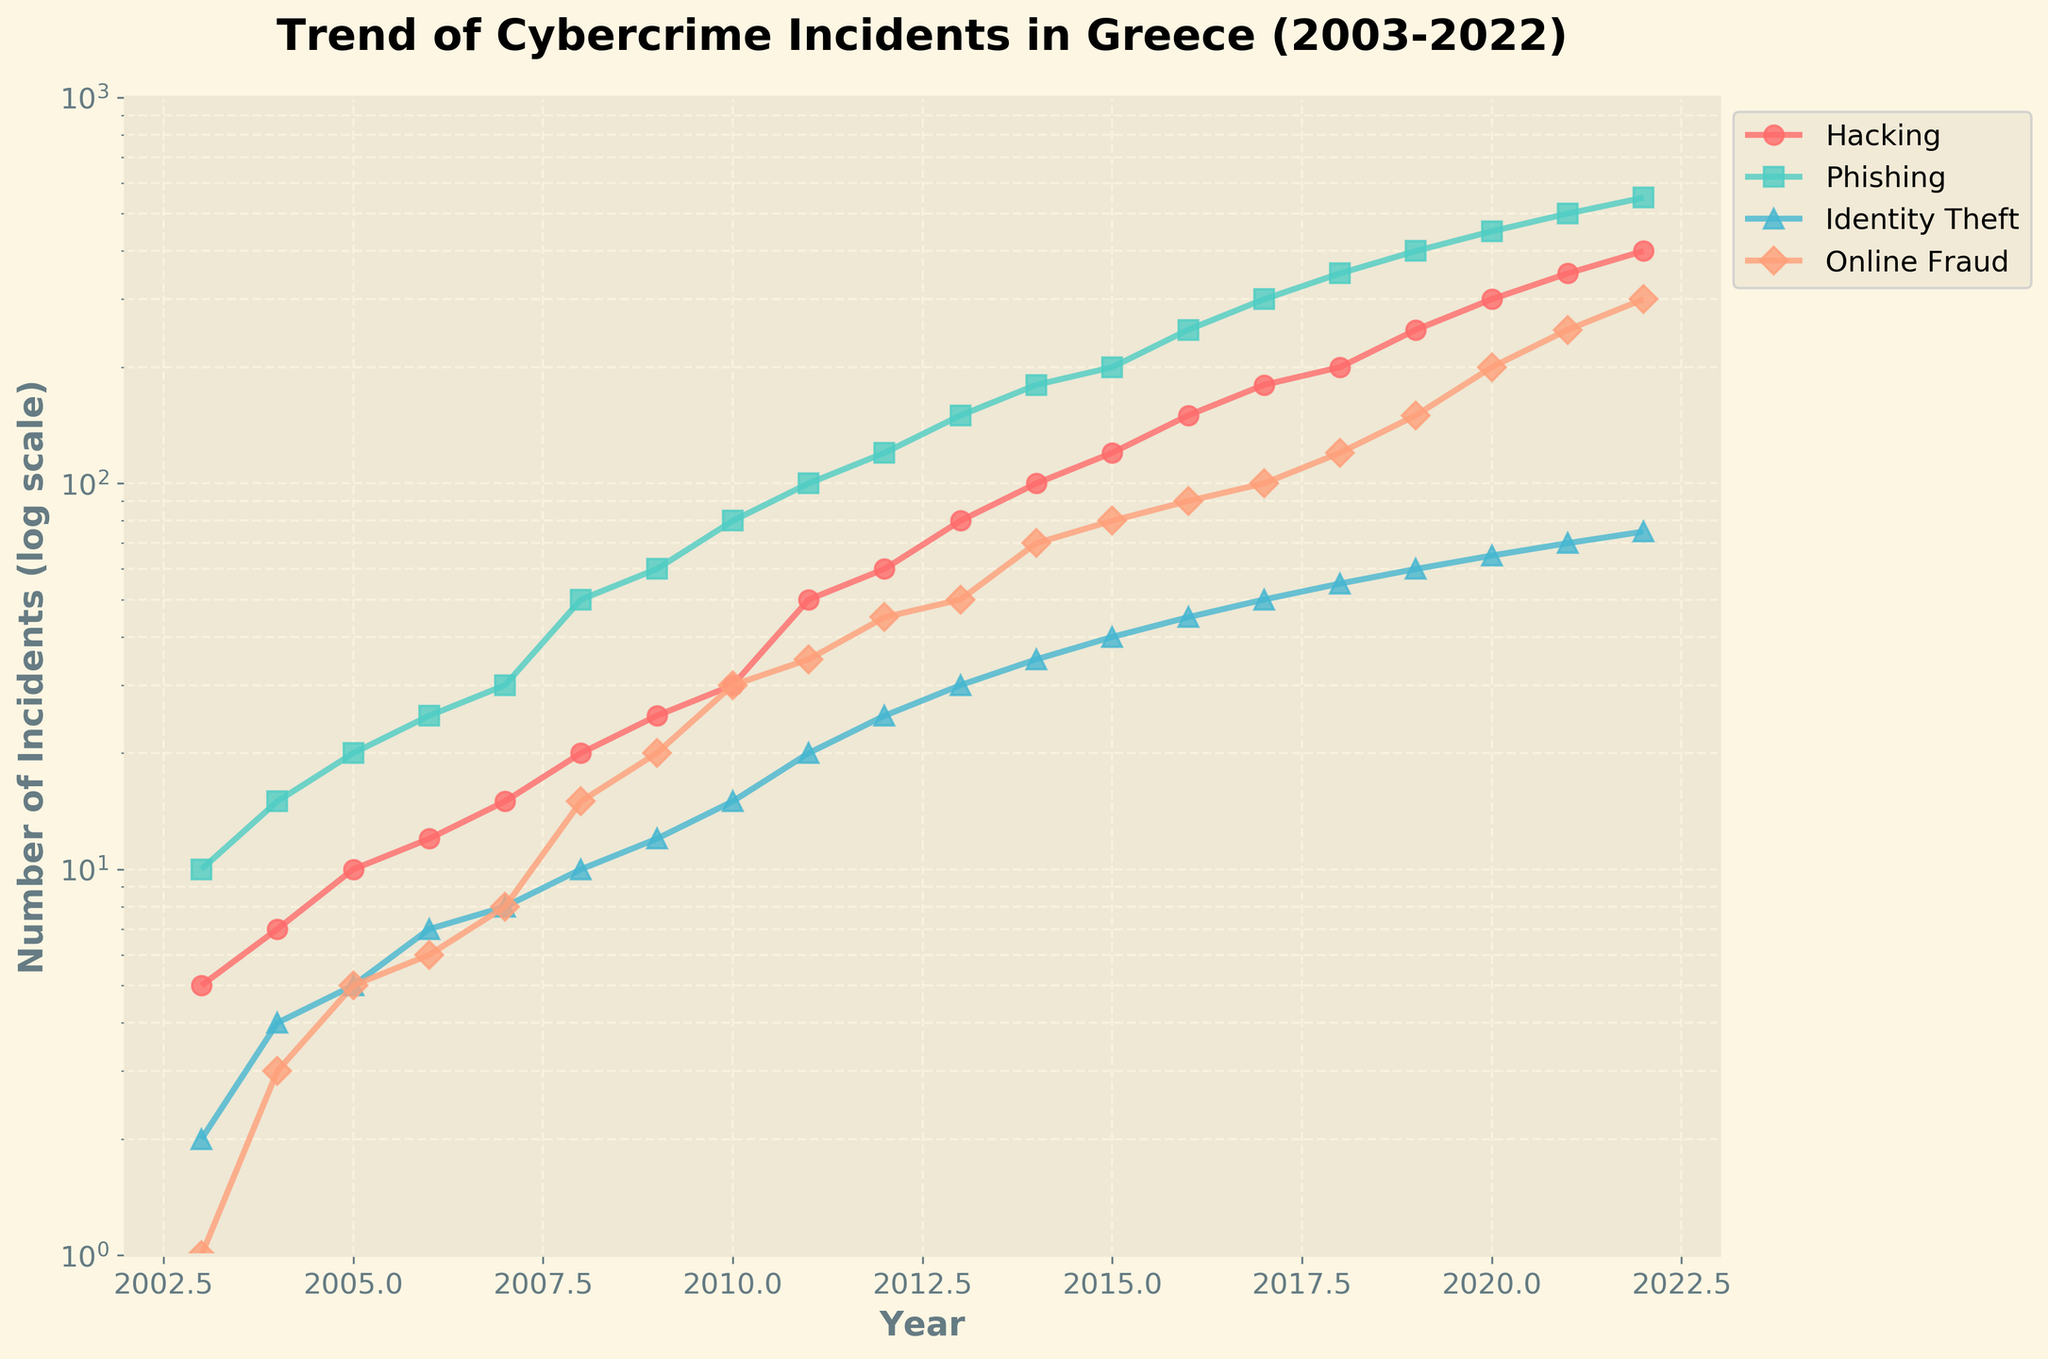What is the overall trend of cybercrime incidents reported in Greece from 2003 to 2022? The overall trend of cybercrime incidents reported in Greece shows a significant increase across all types of offenses over the last 20 years. This can be observed as all lines representing different types of cybercrimes are moving upward.
Answer: Increasing Which type of cybercrime had the highest number of reported incidents by 2022? By examining the end points of the lines for the year 2022, we see that 'Phishing' has the highest number of reported incidents. The line representing 'Phishing' is at the topmost position.
Answer: Phishing How does the increase in 'Identity Theft' incidents from 2003 to 2022 compare to the increase in 'Online Fraud' incidents? 'Identity Theft' incidents increased from 2 in 2003 to 75 in 2022, while 'Online Fraud' incidents increased from 1 in 2003 to 300 in 2022. The increase in 'Online Fraud' incidents is significantly larger than the increase in 'Identity Theft' incidents.
Answer: The increase in 'Online Fraud' incidents is larger In which year did 'Hacking' incidents start to show a steep increase? From the figure, 'Hacking' incidents begin to show a significantly steeper increase around 2017, as indicated by the sharper upward slope of the 'Hacking' line after this year.
Answer: 2017 Do 'Phishing' or 'Hacking' incidents show a greater increase between 2010 and 2020? 'Phishing' incidents increased from 80 in 2010 to 450 in 2020, a difference of 370. 'Hacking' incidents increased from 30 in 2010 to 300 in 2020, a difference of 270. Hence, 'Phishing' shows a greater increase.
Answer: 'Phishing' What is the difference in the number of 'Online Fraud' incidents reported between 2015 and 2022? In 2015, 'Online Fraud' incidents were 80. In 2022, they were 300. The difference is calculated as 300 - 80 = 220.
Answer: 220 Which type of offense exhibited the most consistent upward trend without sharp fluctuations? By observing the plots, 'Hacking' incidents exhibit the most consistent upward trend with relatively smooth and steady increases without sharp fluctuations.
Answer: Hacking How does the growth rate of incidents for 'Phishing' compare to 'Identity Theft' from 2008 to 2012? 'Phishing' incidents increased from 50 in 2008 to 120 in 2012, while 'Identity Theft' incidents increased from 10 in 2008 to 25 in 2012. The growth rate for 'Phishing' is higher given the larger numerical change over this period.
Answer: 'Phishing' has a higher growth rate By which year did 'Hacking' incidents surpass 100? Looking at the 'Hacking' line, it surpasses 100 incidents around 2013.
Answer: 2013 